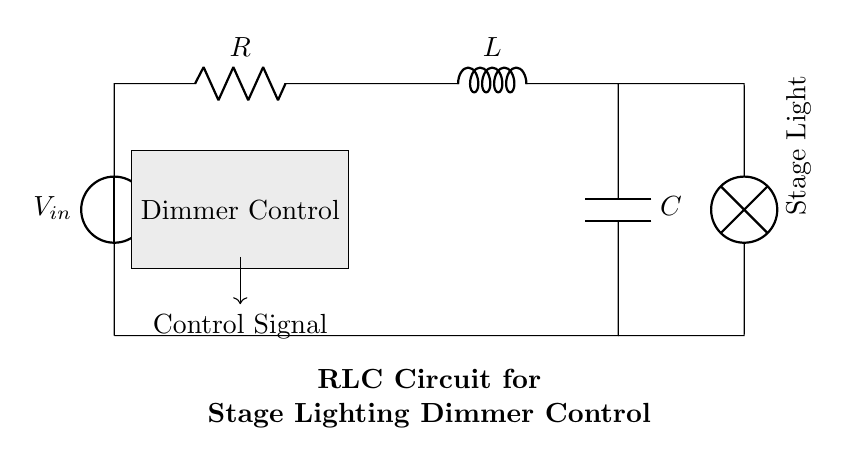What components are in this circuit? The circuit includes a voltage source, a resistor, an inductor, and a capacitor. These components are visibly labeled in the diagram, and together they work in the RLC circuit configuration.
Answer: voltage source, resistor, inductor, capacitor What is the purpose of the lamp in this circuit? The lamp represents the stage light being controlled by the RLC circuit. It is connected in series with the other components to allow for dimming control, adjusting the light intensity based on the control signal from the dimmer.
Answer: stage light How does the dimmer control affect the circuit? The dimmer control modifies the control signal, influencing the power delivered to the lamp by adjusting the resistance, inductance, or capacitance in the circuit. This results in changes to the brightness of the stage light connected after the circuit.
Answer: modifies control signal What type of circuit is shown in the diagram? This is an RLC circuit, characterized by the presence of a resistor, inductor, and capacitor in series, which collectively provide specific electrical characteristics useful for controlling the power and response of the stage lighting system.
Answer: RLC circuit What happens to the current when the dimmer control is adjusted? When the dimmer control is adjusted, it alters the phase relationship between the voltage and current in the circuit due to varying resistance, inductance, or capacitance, leading to changes in the current magnitude flowing to the stage light, thus dimming or brightening it.
Answer: changes current magnitude What is the relationship between R, L, and C in this circuit? The resistor, inductor, and capacitor work together to determine the overall impedance and frequency response of the circuit. The combination of these elements affects how the circuit responds to the input voltage and control signal, combining resistive, inductive, and capacitive effects.
Answer: determines impedance and frequency response How does the RLC circuit help in stage lighting control? The RLC circuit provides a means to modulate the light intensity through adjustments in impedance that directly influence the current supplied to the lighting system. By balancing these components, one can achieve smoother dimming effects for theatrical performances.
Answer: modulates light intensity 